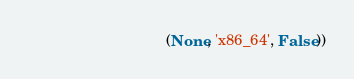<code> <loc_0><loc_0><loc_500><loc_500><_Python_>                                 (None, 'x86_64', False))
</code> 